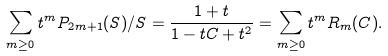<formula> <loc_0><loc_0><loc_500><loc_500>\sum _ { m \geq 0 } t ^ { m } P _ { 2 m + 1 } ( S ) / S = \frac { 1 + t } { 1 - t C + t ^ { 2 } } = \sum _ { m \geq 0 } t ^ { m } R _ { m } ( C ) .</formula> 